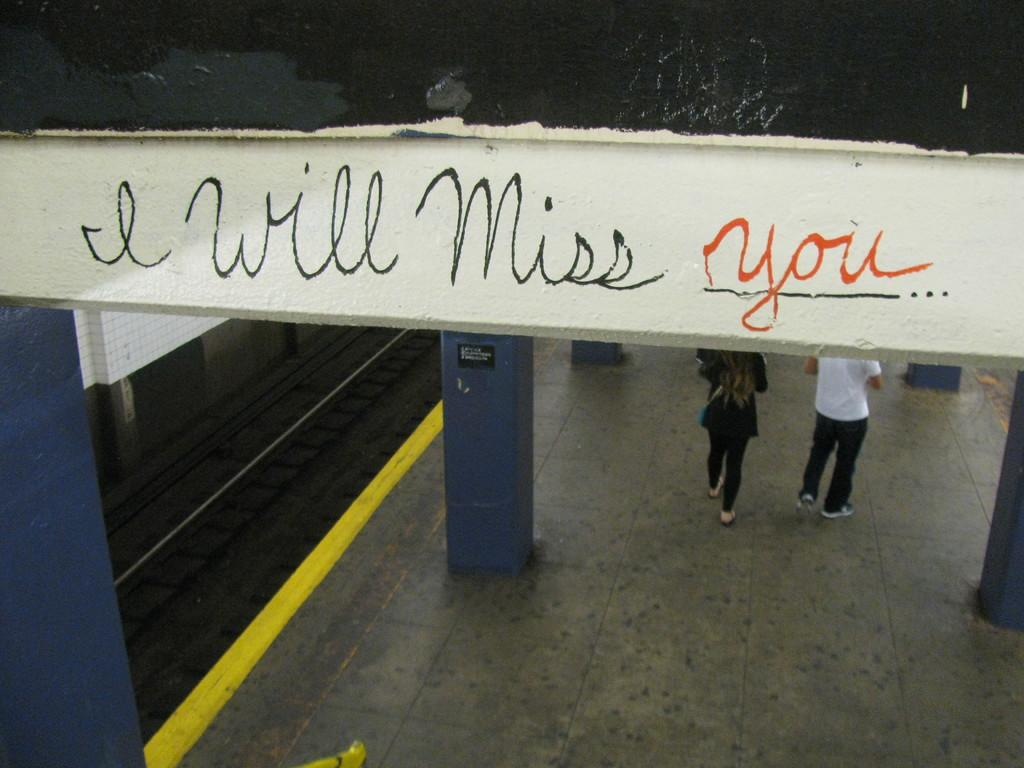How many people are present in the image? There are two persons standing in the image. What architectural features can be seen in the image? There are pillars and an arch visible in the image. What is written or depicted on the arch? There are words on the arch. What type of flowers are growing on the support beams in the image? There are no flowers present in the image, and the architectural features are referred to as pillars, not support beams. 